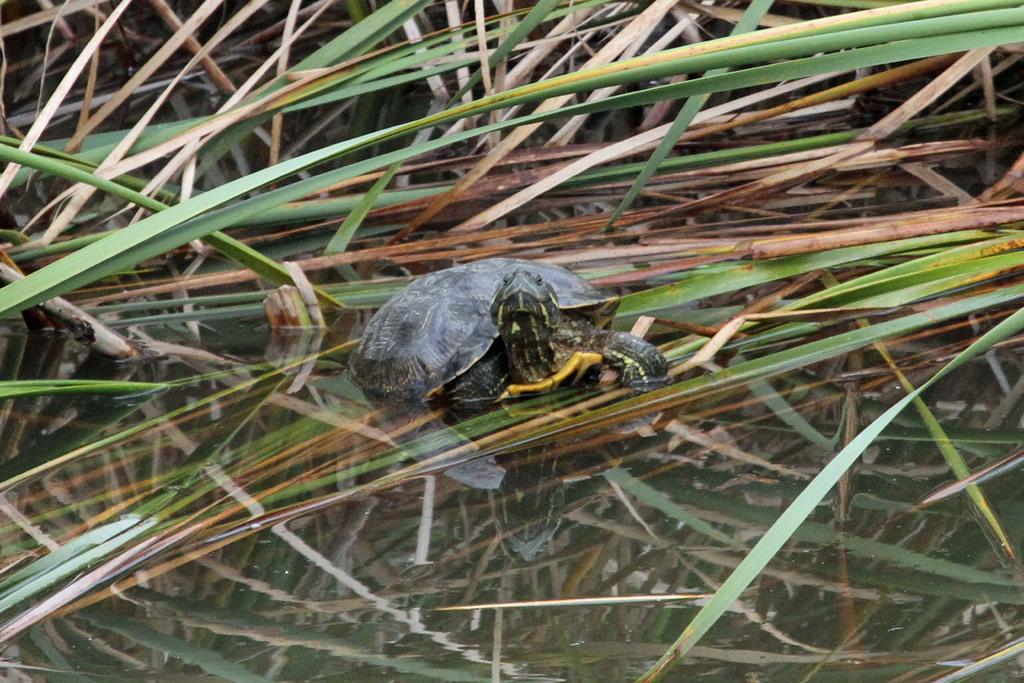What type of animal is in the image? There is a tortoise in the image. Where is the tortoise located? The tortoise is on the grass. What colors can be seen on the tortoise? The tortoise has brown and black coloring. What color is the grass in the image? The grass is green. How many toes can be seen on the tortoise in the image? Tortoises do not have toes; they have claws. However, in the image, no claws or any other body parts of the tortoise are visible. 